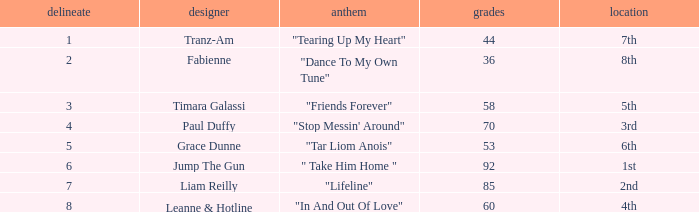What's the average draw for the song "stop messin' around"? 4.0. 